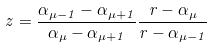Convert formula to latex. <formula><loc_0><loc_0><loc_500><loc_500>z = \frac { \alpha _ { \mu - 1 } - \alpha _ { \mu + 1 } } { \alpha _ { \mu } - \alpha _ { \mu + 1 } } \frac { r - \alpha _ { \mu } } { r - \alpha _ { \mu - 1 } }</formula> 